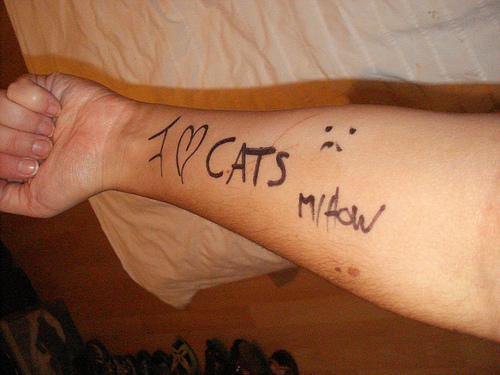<image>
Is the word on the paper? No. The word is not positioned on the paper. They may be near each other, but the word is not supported by or resting on top of the paper. 